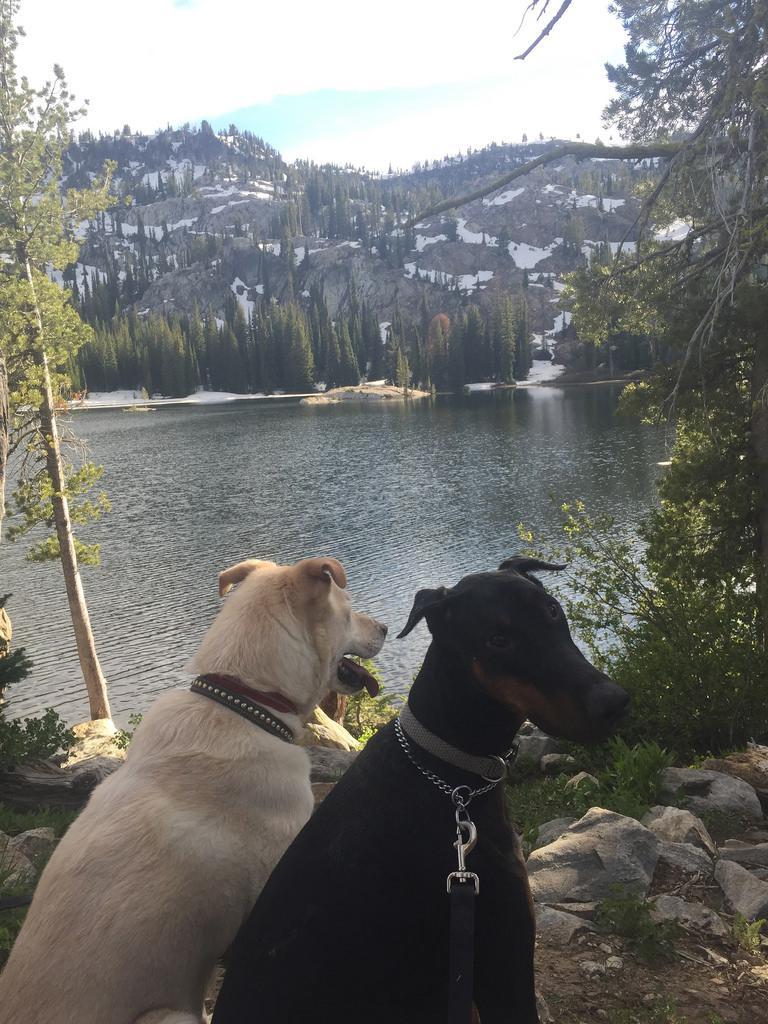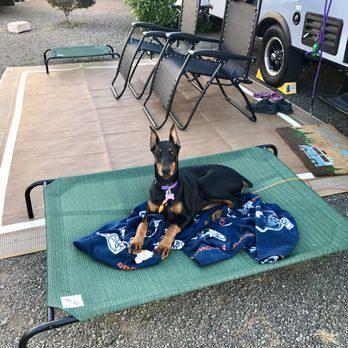The first image is the image on the left, the second image is the image on the right. Given the left and right images, does the statement "There is at least one human to the left of the dog." hold true? Answer yes or no. No. The first image is the image on the left, the second image is the image on the right. Analyze the images presented: Is the assertion "A dog is laying on a blanket." valid? Answer yes or no. Yes. 